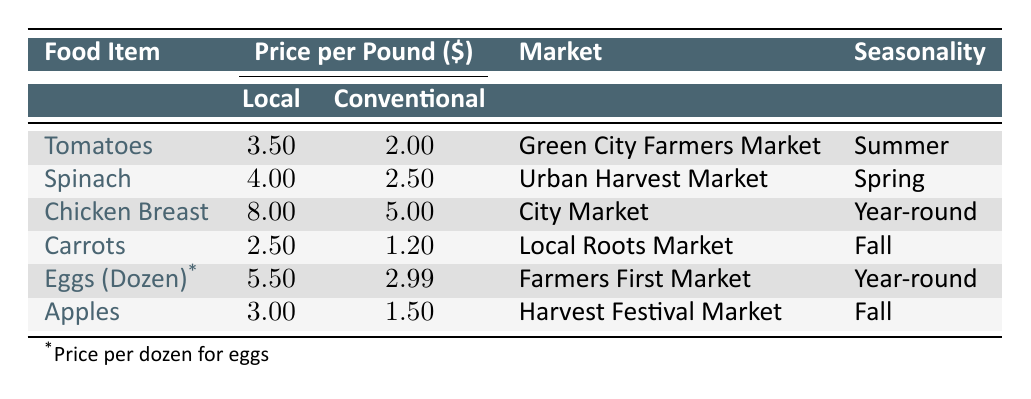What is the price per pound of local tomatoes? The table lists the price per pound for local tomatoes as 3.50.
Answer: 3.50 What is the total price difference for local versus conventional chicken breast? The local price for chicken breast is 8.00, and the conventional price is 5.00. The difference is 8.00 - 5.00 = 3.00.
Answer: 3.00 Is the price of local spinach lower than that of conventional spinach? From the table, the local price of spinach is 4.00, while the conventional price is 2.50. Thus, local spinach is not lower.
Answer: No Which food item has the highest price per pound in the local category? Looking at the table, chicken breast at 8.00 is higher than any other local prices: tomatoes (3.50), spinach (4.00), carrots (2.50), and apples (3.00).
Answer: Chicken Breast What is the average price per pound of conventional carrots and apples? The conventional price of carrots is 1.20 and apples is 1.50. The average is (1.20 + 1.50) / 2 = 1.35.
Answer: 1.35 Are local eggs more expensive than conventional eggs? The local price for a dozen eggs is 5.50, while the conventional price is 2.99. Therefore, local eggs are indeed more expensive.
Answer: Yes Which market has the highest local price for fruits or vegetables? The highest local price is 8.00 for chicken breast at City Market, while for fruits and vegetables, tomatoes (3.50) from Green City Farmers Market is the highest. No fruit exceeds this price.
Answer: City Market What is the combined local price per pound for tomatoes and spinach? The local price for tomatoes is 3.50 and for spinach is 4.00. Adding these gives a total of 3.50 + 4.00 = 7.50.
Answer: 7.50 